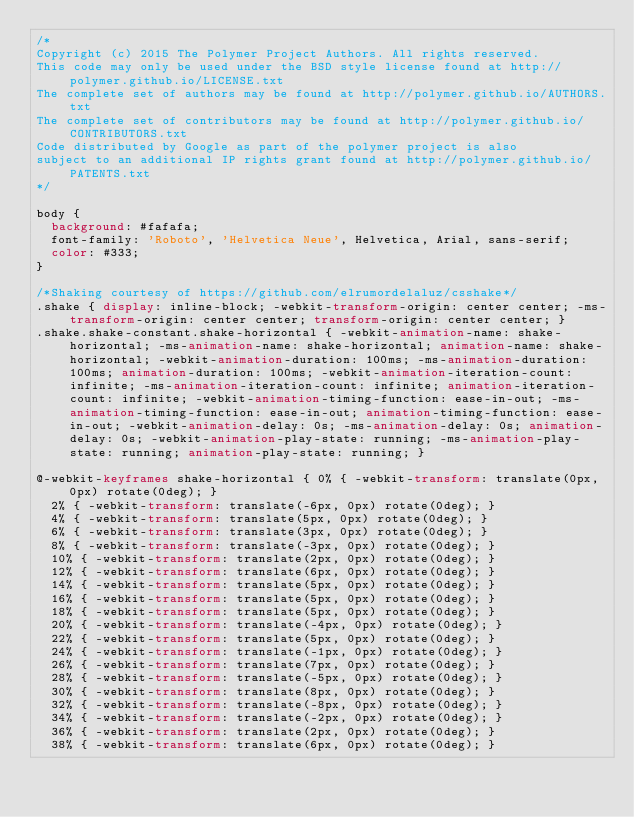Convert code to text. <code><loc_0><loc_0><loc_500><loc_500><_CSS_>/*
Copyright (c) 2015 The Polymer Project Authors. All rights reserved.
This code may only be used under the BSD style license found at http://polymer.github.io/LICENSE.txt
The complete set of authors may be found at http://polymer.github.io/AUTHORS.txt
The complete set of contributors may be found at http://polymer.github.io/CONTRIBUTORS.txt
Code distributed by Google as part of the polymer project is also
subject to an additional IP rights grant found at http://polymer.github.io/PATENTS.txt
*/

body {
  background: #fafafa;
  font-family: 'Roboto', 'Helvetica Neue', Helvetica, Arial, sans-serif;
  color: #333;
}

/*Shaking courtesy of https://github.com/elrumordelaluz/csshake*/
.shake { display: inline-block; -webkit-transform-origin: center center; -ms-transform-origin: center center; transform-origin: center center; }
.shake.shake-constant.shake-horizontal { -webkit-animation-name: shake-horizontal; -ms-animation-name: shake-horizontal; animation-name: shake-horizontal; -webkit-animation-duration: 100ms; -ms-animation-duration: 100ms; animation-duration: 100ms; -webkit-animation-iteration-count: infinite; -ms-animation-iteration-count: infinite; animation-iteration-count: infinite; -webkit-animation-timing-function: ease-in-out; -ms-animation-timing-function: ease-in-out; animation-timing-function: ease-in-out; -webkit-animation-delay: 0s; -ms-animation-delay: 0s; animation-delay: 0s; -webkit-animation-play-state: running; -ms-animation-play-state: running; animation-play-state: running; }

@-webkit-keyframes shake-horizontal { 0% { -webkit-transform: translate(0px, 0px) rotate(0deg); }
  2% { -webkit-transform: translate(-6px, 0px) rotate(0deg); }
  4% { -webkit-transform: translate(5px, 0px) rotate(0deg); }
  6% { -webkit-transform: translate(3px, 0px) rotate(0deg); }
  8% { -webkit-transform: translate(-3px, 0px) rotate(0deg); }
  10% { -webkit-transform: translate(2px, 0px) rotate(0deg); }
  12% { -webkit-transform: translate(6px, 0px) rotate(0deg); }
  14% { -webkit-transform: translate(5px, 0px) rotate(0deg); }
  16% { -webkit-transform: translate(5px, 0px) rotate(0deg); }
  18% { -webkit-transform: translate(5px, 0px) rotate(0deg); }
  20% { -webkit-transform: translate(-4px, 0px) rotate(0deg); }
  22% { -webkit-transform: translate(5px, 0px) rotate(0deg); }
  24% { -webkit-transform: translate(-1px, 0px) rotate(0deg); }
  26% { -webkit-transform: translate(7px, 0px) rotate(0deg); }
  28% { -webkit-transform: translate(-5px, 0px) rotate(0deg); }
  30% { -webkit-transform: translate(8px, 0px) rotate(0deg); }
  32% { -webkit-transform: translate(-8px, 0px) rotate(0deg); }
  34% { -webkit-transform: translate(-2px, 0px) rotate(0deg); }
  36% { -webkit-transform: translate(2px, 0px) rotate(0deg); }
  38% { -webkit-transform: translate(6px, 0px) rotate(0deg); }</code> 